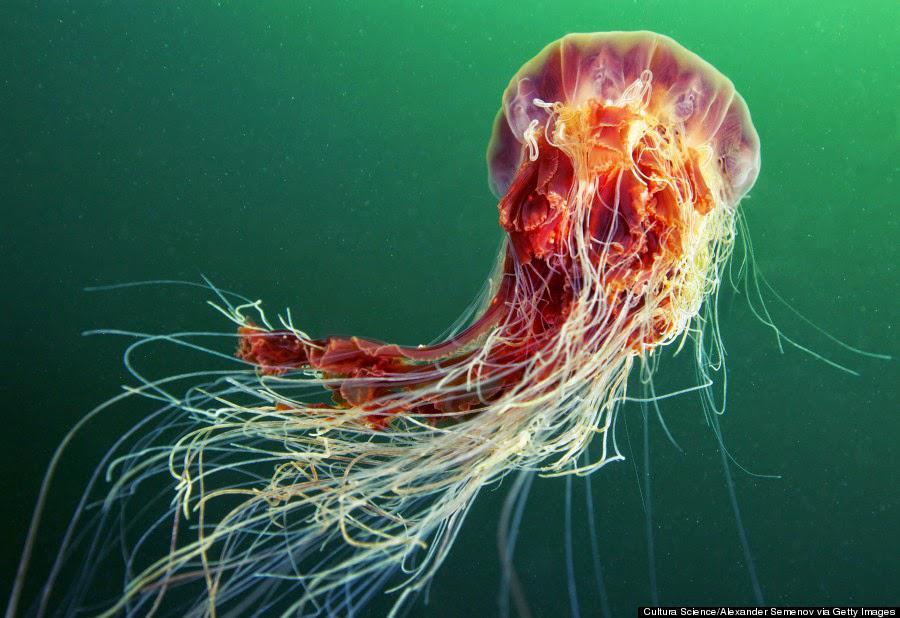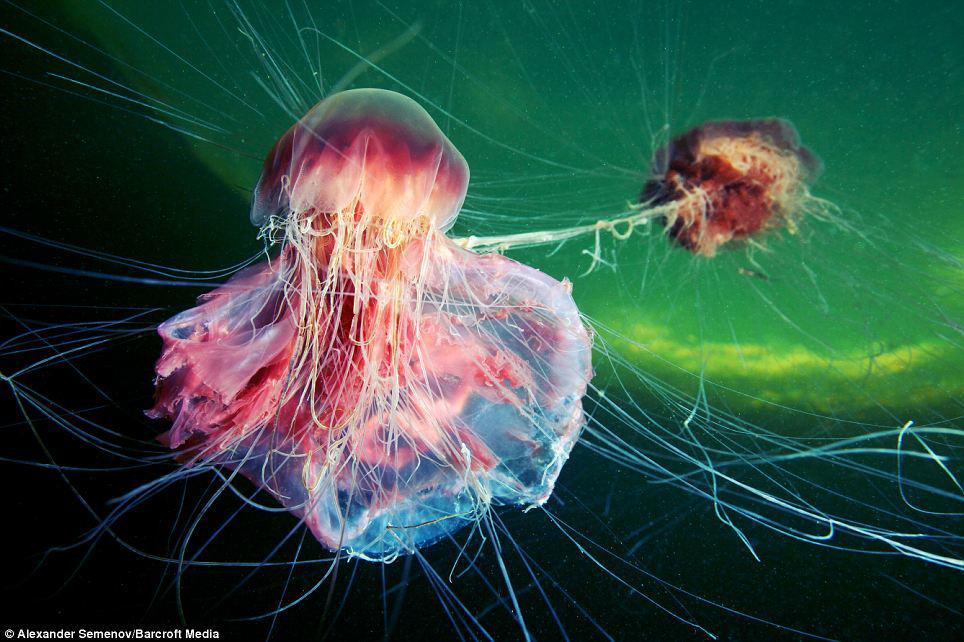The first image is the image on the left, the second image is the image on the right. Given the left and right images, does the statement "An image shows a mushroom-shaped purplish jellyfish with tentacles reaching in all directions and enveloping at least one other creature." hold true? Answer yes or no. Yes. The first image is the image on the left, the second image is the image on the right. Considering the images on both sides, is "in at least one image there is at least two jellyfish with at least one that is both red, black and fire colored." valid? Answer yes or no. Yes. 